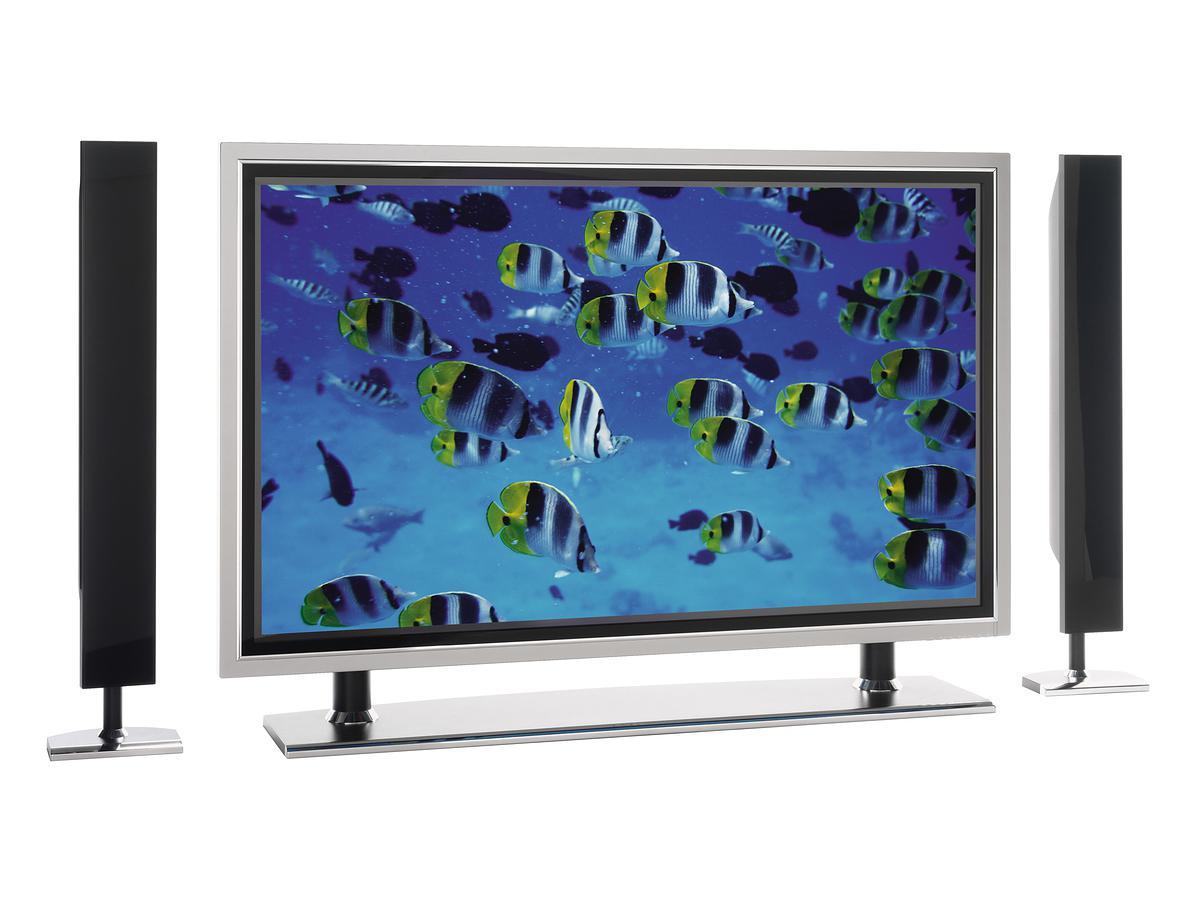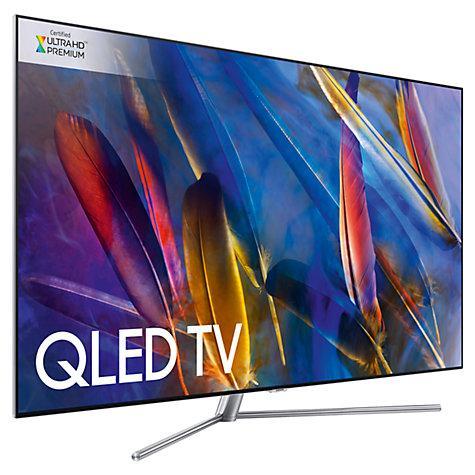The first image is the image on the left, the second image is the image on the right. Evaluate the accuracy of this statement regarding the images: "Atleast one tv has an image of something alive.". Is it true? Answer yes or no. Yes. 